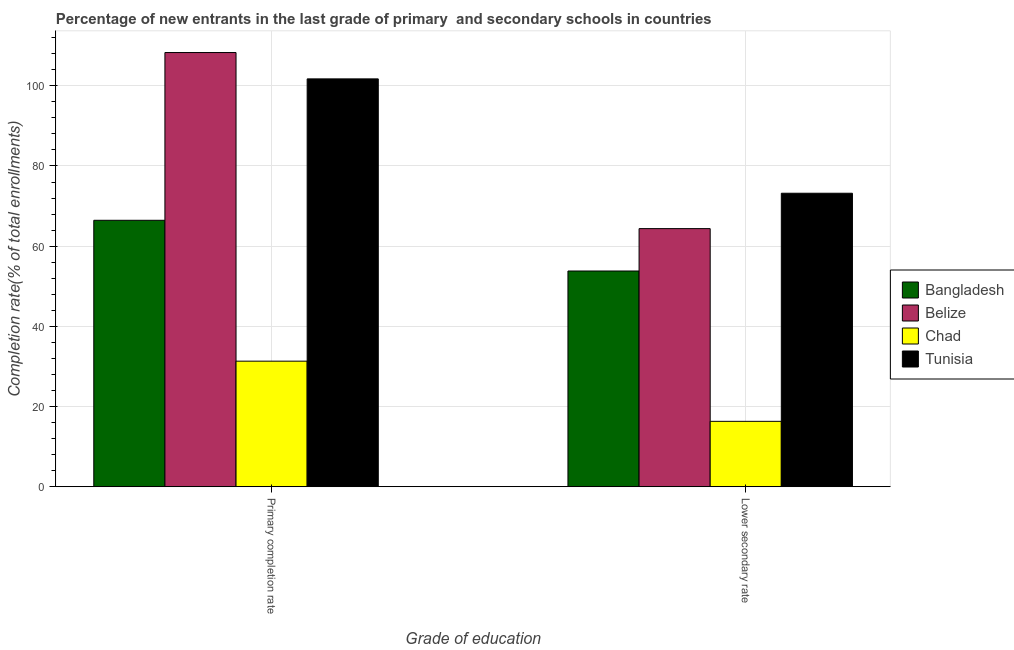How many groups of bars are there?
Provide a succinct answer. 2. Are the number of bars per tick equal to the number of legend labels?
Ensure brevity in your answer.  Yes. What is the label of the 1st group of bars from the left?
Give a very brief answer. Primary completion rate. What is the completion rate in primary schools in Chad?
Keep it short and to the point. 31.32. Across all countries, what is the maximum completion rate in primary schools?
Offer a terse response. 108.3. Across all countries, what is the minimum completion rate in secondary schools?
Offer a very short reply. 16.31. In which country was the completion rate in secondary schools maximum?
Your response must be concise. Tunisia. In which country was the completion rate in secondary schools minimum?
Your response must be concise. Chad. What is the total completion rate in primary schools in the graph?
Offer a terse response. 307.79. What is the difference between the completion rate in primary schools in Chad and that in Belize?
Make the answer very short. -76.98. What is the difference between the completion rate in primary schools in Chad and the completion rate in secondary schools in Tunisia?
Your answer should be compact. -41.88. What is the average completion rate in primary schools per country?
Keep it short and to the point. 76.95. What is the difference between the completion rate in primary schools and completion rate in secondary schools in Tunisia?
Your response must be concise. 28.52. In how many countries, is the completion rate in secondary schools greater than 64 %?
Offer a terse response. 2. What is the ratio of the completion rate in secondary schools in Belize to that in Chad?
Give a very brief answer. 3.95. Is the completion rate in primary schools in Belize less than that in Chad?
Offer a very short reply. No. What does the 2nd bar from the left in Primary completion rate represents?
Your response must be concise. Belize. What does the 3rd bar from the right in Lower secondary rate represents?
Make the answer very short. Belize. How many countries are there in the graph?
Ensure brevity in your answer.  4. What is the difference between two consecutive major ticks on the Y-axis?
Provide a succinct answer. 20. Are the values on the major ticks of Y-axis written in scientific E-notation?
Keep it short and to the point. No. Does the graph contain grids?
Give a very brief answer. Yes. Where does the legend appear in the graph?
Offer a very short reply. Center right. What is the title of the graph?
Provide a succinct answer. Percentage of new entrants in the last grade of primary  and secondary schools in countries. What is the label or title of the X-axis?
Your answer should be very brief. Grade of education. What is the label or title of the Y-axis?
Ensure brevity in your answer.  Completion rate(% of total enrollments). What is the Completion rate(% of total enrollments) of Bangladesh in Primary completion rate?
Keep it short and to the point. 66.45. What is the Completion rate(% of total enrollments) in Belize in Primary completion rate?
Make the answer very short. 108.3. What is the Completion rate(% of total enrollments) in Chad in Primary completion rate?
Keep it short and to the point. 31.32. What is the Completion rate(% of total enrollments) in Tunisia in Primary completion rate?
Offer a very short reply. 101.72. What is the Completion rate(% of total enrollments) of Bangladesh in Lower secondary rate?
Ensure brevity in your answer.  53.81. What is the Completion rate(% of total enrollments) of Belize in Lower secondary rate?
Ensure brevity in your answer.  64.38. What is the Completion rate(% of total enrollments) in Chad in Lower secondary rate?
Your response must be concise. 16.31. What is the Completion rate(% of total enrollments) of Tunisia in Lower secondary rate?
Provide a short and direct response. 73.2. Across all Grade of education, what is the maximum Completion rate(% of total enrollments) in Bangladesh?
Your answer should be compact. 66.45. Across all Grade of education, what is the maximum Completion rate(% of total enrollments) of Belize?
Make the answer very short. 108.3. Across all Grade of education, what is the maximum Completion rate(% of total enrollments) in Chad?
Give a very brief answer. 31.32. Across all Grade of education, what is the maximum Completion rate(% of total enrollments) in Tunisia?
Keep it short and to the point. 101.72. Across all Grade of education, what is the minimum Completion rate(% of total enrollments) in Bangladesh?
Make the answer very short. 53.81. Across all Grade of education, what is the minimum Completion rate(% of total enrollments) in Belize?
Keep it short and to the point. 64.38. Across all Grade of education, what is the minimum Completion rate(% of total enrollments) of Chad?
Offer a very short reply. 16.31. Across all Grade of education, what is the minimum Completion rate(% of total enrollments) of Tunisia?
Provide a short and direct response. 73.2. What is the total Completion rate(% of total enrollments) of Bangladesh in the graph?
Make the answer very short. 120.26. What is the total Completion rate(% of total enrollments) of Belize in the graph?
Your answer should be compact. 172.68. What is the total Completion rate(% of total enrollments) in Chad in the graph?
Your answer should be compact. 47.62. What is the total Completion rate(% of total enrollments) in Tunisia in the graph?
Your answer should be very brief. 174.92. What is the difference between the Completion rate(% of total enrollments) in Bangladesh in Primary completion rate and that in Lower secondary rate?
Your response must be concise. 12.65. What is the difference between the Completion rate(% of total enrollments) in Belize in Primary completion rate and that in Lower secondary rate?
Your answer should be very brief. 43.92. What is the difference between the Completion rate(% of total enrollments) in Chad in Primary completion rate and that in Lower secondary rate?
Keep it short and to the point. 15.01. What is the difference between the Completion rate(% of total enrollments) in Tunisia in Primary completion rate and that in Lower secondary rate?
Keep it short and to the point. 28.52. What is the difference between the Completion rate(% of total enrollments) of Bangladesh in Primary completion rate and the Completion rate(% of total enrollments) of Belize in Lower secondary rate?
Make the answer very short. 2.08. What is the difference between the Completion rate(% of total enrollments) of Bangladesh in Primary completion rate and the Completion rate(% of total enrollments) of Chad in Lower secondary rate?
Your answer should be very brief. 50.15. What is the difference between the Completion rate(% of total enrollments) of Bangladesh in Primary completion rate and the Completion rate(% of total enrollments) of Tunisia in Lower secondary rate?
Give a very brief answer. -6.75. What is the difference between the Completion rate(% of total enrollments) of Belize in Primary completion rate and the Completion rate(% of total enrollments) of Chad in Lower secondary rate?
Offer a very short reply. 91.99. What is the difference between the Completion rate(% of total enrollments) of Belize in Primary completion rate and the Completion rate(% of total enrollments) of Tunisia in Lower secondary rate?
Give a very brief answer. 35.1. What is the difference between the Completion rate(% of total enrollments) of Chad in Primary completion rate and the Completion rate(% of total enrollments) of Tunisia in Lower secondary rate?
Ensure brevity in your answer.  -41.88. What is the average Completion rate(% of total enrollments) in Bangladesh per Grade of education?
Provide a succinct answer. 60.13. What is the average Completion rate(% of total enrollments) of Belize per Grade of education?
Your answer should be compact. 86.34. What is the average Completion rate(% of total enrollments) of Chad per Grade of education?
Your answer should be very brief. 23.81. What is the average Completion rate(% of total enrollments) of Tunisia per Grade of education?
Give a very brief answer. 87.46. What is the difference between the Completion rate(% of total enrollments) of Bangladesh and Completion rate(% of total enrollments) of Belize in Primary completion rate?
Provide a short and direct response. -41.84. What is the difference between the Completion rate(% of total enrollments) in Bangladesh and Completion rate(% of total enrollments) in Chad in Primary completion rate?
Keep it short and to the point. 35.14. What is the difference between the Completion rate(% of total enrollments) in Bangladesh and Completion rate(% of total enrollments) in Tunisia in Primary completion rate?
Keep it short and to the point. -35.27. What is the difference between the Completion rate(% of total enrollments) in Belize and Completion rate(% of total enrollments) in Chad in Primary completion rate?
Provide a succinct answer. 76.98. What is the difference between the Completion rate(% of total enrollments) of Belize and Completion rate(% of total enrollments) of Tunisia in Primary completion rate?
Give a very brief answer. 6.57. What is the difference between the Completion rate(% of total enrollments) in Chad and Completion rate(% of total enrollments) in Tunisia in Primary completion rate?
Keep it short and to the point. -70.41. What is the difference between the Completion rate(% of total enrollments) in Bangladesh and Completion rate(% of total enrollments) in Belize in Lower secondary rate?
Give a very brief answer. -10.57. What is the difference between the Completion rate(% of total enrollments) in Bangladesh and Completion rate(% of total enrollments) in Chad in Lower secondary rate?
Provide a succinct answer. 37.5. What is the difference between the Completion rate(% of total enrollments) in Bangladesh and Completion rate(% of total enrollments) in Tunisia in Lower secondary rate?
Your answer should be very brief. -19.39. What is the difference between the Completion rate(% of total enrollments) in Belize and Completion rate(% of total enrollments) in Chad in Lower secondary rate?
Your response must be concise. 48.07. What is the difference between the Completion rate(% of total enrollments) of Belize and Completion rate(% of total enrollments) of Tunisia in Lower secondary rate?
Give a very brief answer. -8.82. What is the difference between the Completion rate(% of total enrollments) of Chad and Completion rate(% of total enrollments) of Tunisia in Lower secondary rate?
Provide a succinct answer. -56.89. What is the ratio of the Completion rate(% of total enrollments) in Bangladesh in Primary completion rate to that in Lower secondary rate?
Your answer should be very brief. 1.24. What is the ratio of the Completion rate(% of total enrollments) of Belize in Primary completion rate to that in Lower secondary rate?
Ensure brevity in your answer.  1.68. What is the ratio of the Completion rate(% of total enrollments) in Chad in Primary completion rate to that in Lower secondary rate?
Offer a terse response. 1.92. What is the ratio of the Completion rate(% of total enrollments) of Tunisia in Primary completion rate to that in Lower secondary rate?
Your answer should be compact. 1.39. What is the difference between the highest and the second highest Completion rate(% of total enrollments) of Bangladesh?
Make the answer very short. 12.65. What is the difference between the highest and the second highest Completion rate(% of total enrollments) of Belize?
Ensure brevity in your answer.  43.92. What is the difference between the highest and the second highest Completion rate(% of total enrollments) in Chad?
Give a very brief answer. 15.01. What is the difference between the highest and the second highest Completion rate(% of total enrollments) of Tunisia?
Your response must be concise. 28.52. What is the difference between the highest and the lowest Completion rate(% of total enrollments) in Bangladesh?
Offer a very short reply. 12.65. What is the difference between the highest and the lowest Completion rate(% of total enrollments) in Belize?
Your answer should be very brief. 43.92. What is the difference between the highest and the lowest Completion rate(% of total enrollments) of Chad?
Your answer should be compact. 15.01. What is the difference between the highest and the lowest Completion rate(% of total enrollments) in Tunisia?
Give a very brief answer. 28.52. 